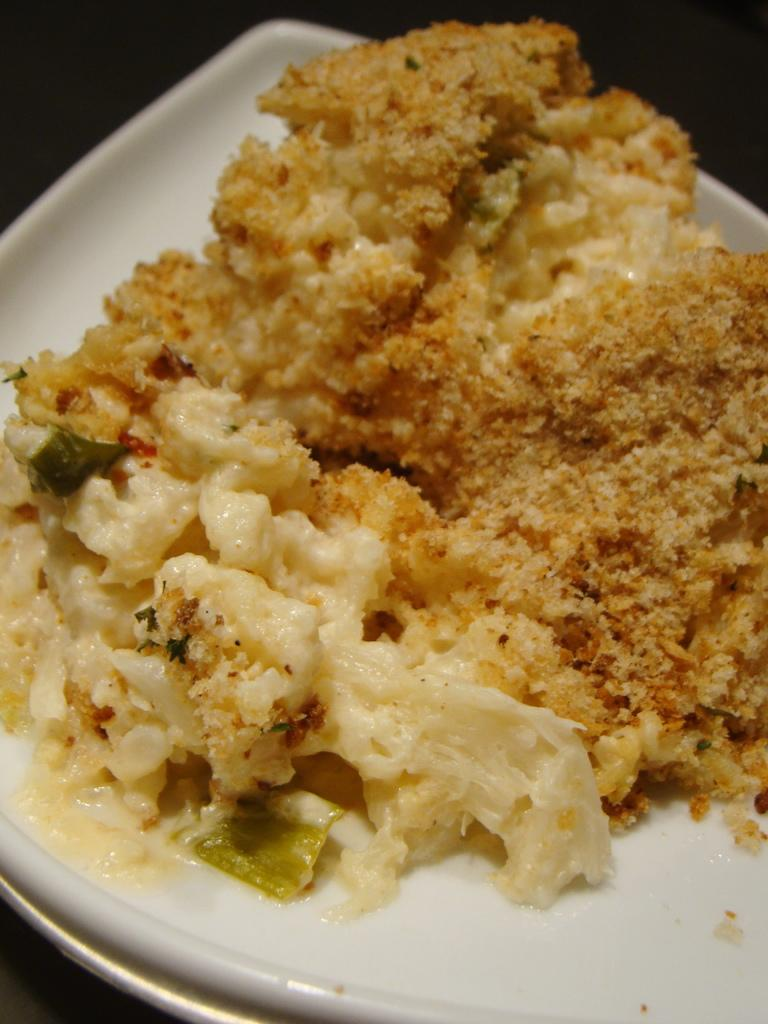What color is the plate that is visible in the image? The plate in the image is white. What is on the plate in the image? There is food on the plate in the image. What type of jewel is featured in the band's performance in the image? There is no band or performance present in the image, so there is no jewel featured. 